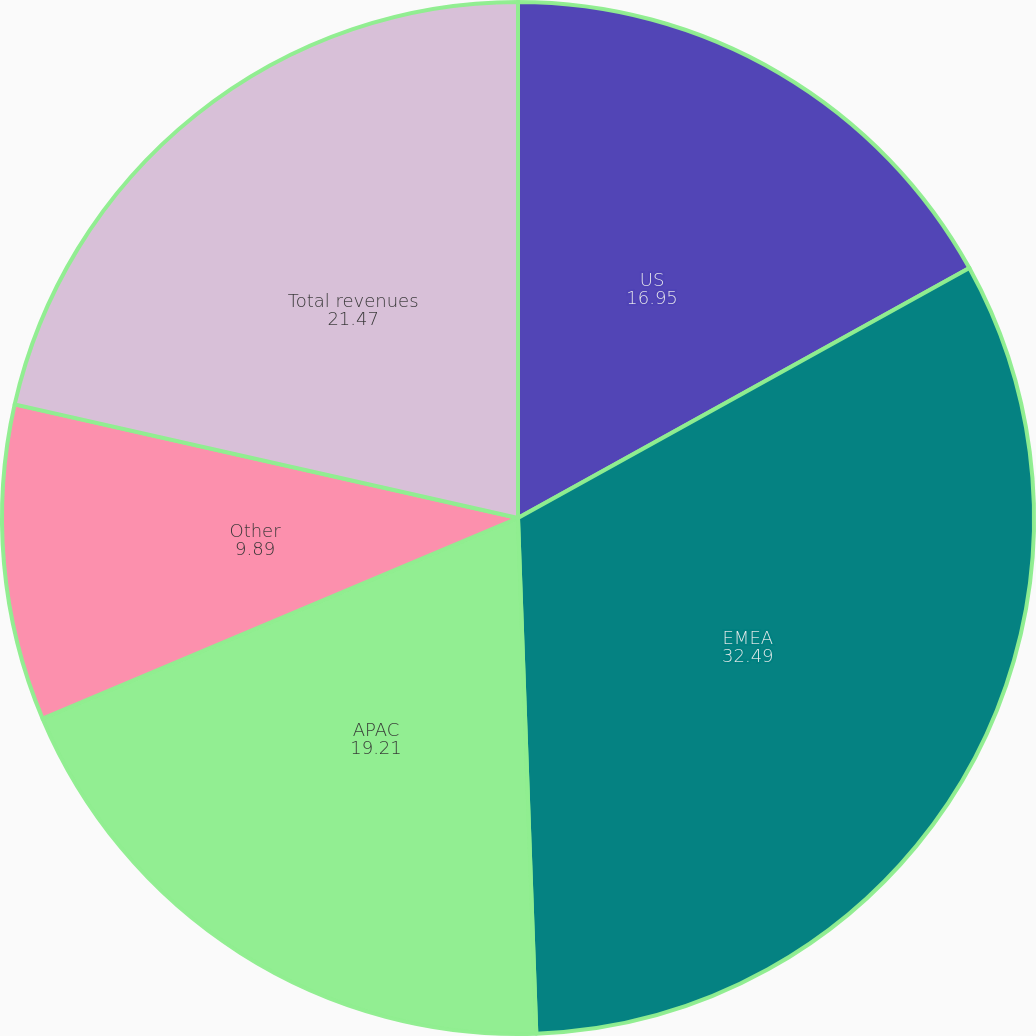Convert chart to OTSL. <chart><loc_0><loc_0><loc_500><loc_500><pie_chart><fcel>US<fcel>EMEA<fcel>APAC<fcel>Other<fcel>Total revenues<nl><fcel>16.95%<fcel>32.49%<fcel>19.21%<fcel>9.89%<fcel>21.47%<nl></chart> 